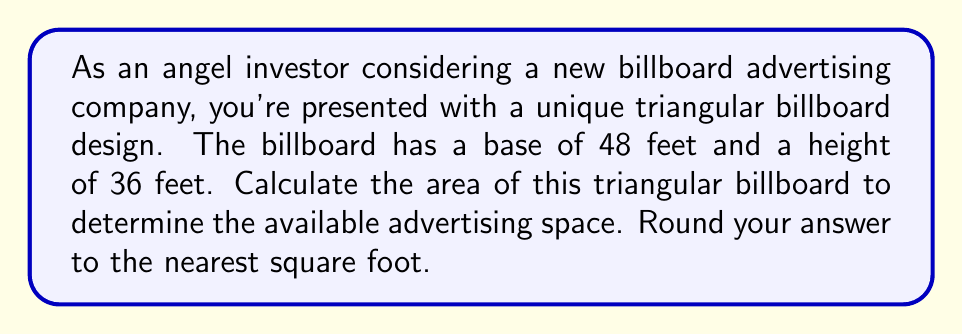Show me your answer to this math problem. To solve this problem, we need to use the formula for the area of a triangle:

$$A = \frac{1}{2} \times b \times h$$

Where:
$A$ = Area of the triangle
$b$ = Base of the triangle
$h$ = Height of the triangle

Given:
Base $(b) = 48$ feet
Height $(h) = 36$ feet

Let's substitute these values into the formula:

$$A = \frac{1}{2} \times 48 \times 36$$

Now, let's calculate:

$$A = \frac{1}{2} \times 1728$$
$$A = 864$$

Therefore, the area of the triangular billboard is 864 square feet.

[asy]
unitsize(4);
draw((0,0)--(12,0)--(6,9)--cycle);
draw((6,0)--(6,9),dashed);
label("48 ft", (6,0), S);
label("36 ft", (6,4.5), E);
label("Area = ?", (6,3), W);
[/asy]
Answer: 864 square feet 